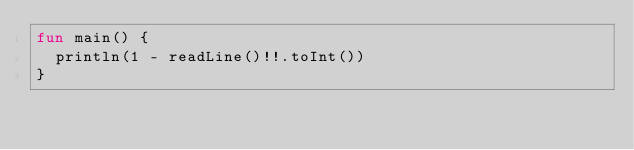Convert code to text. <code><loc_0><loc_0><loc_500><loc_500><_Kotlin_>fun main() {
	println(1 - readLine()!!.toInt())
}</code> 